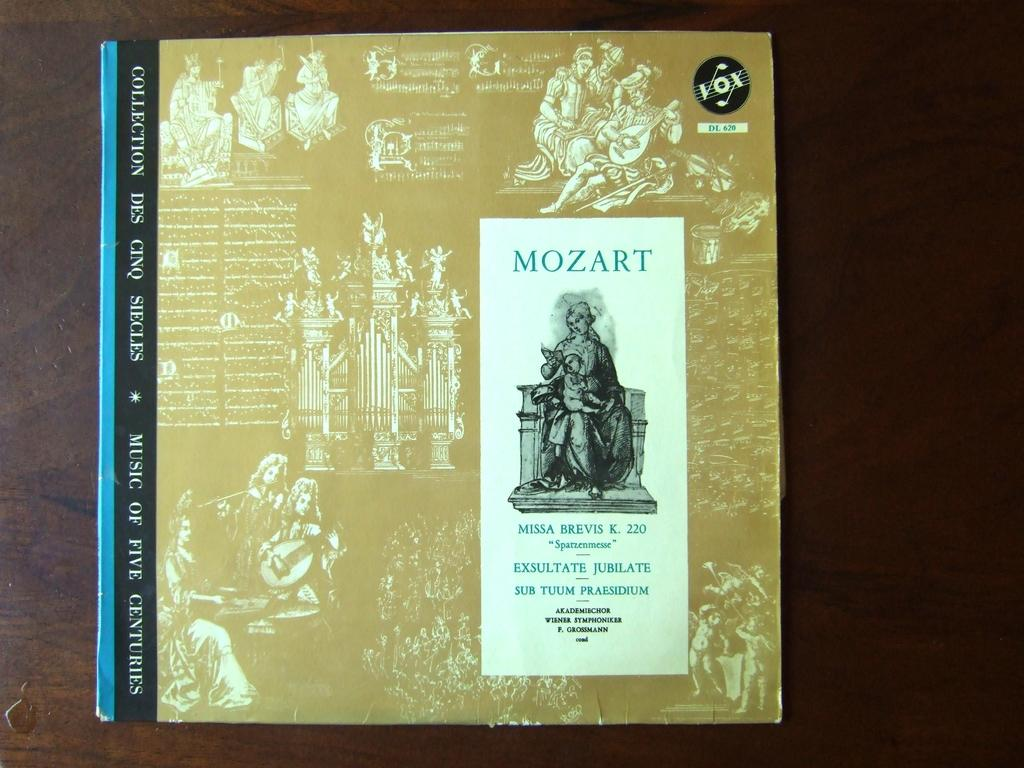<image>
Present a compact description of the photo's key features. a booklet of mozart it looks like its a music book 